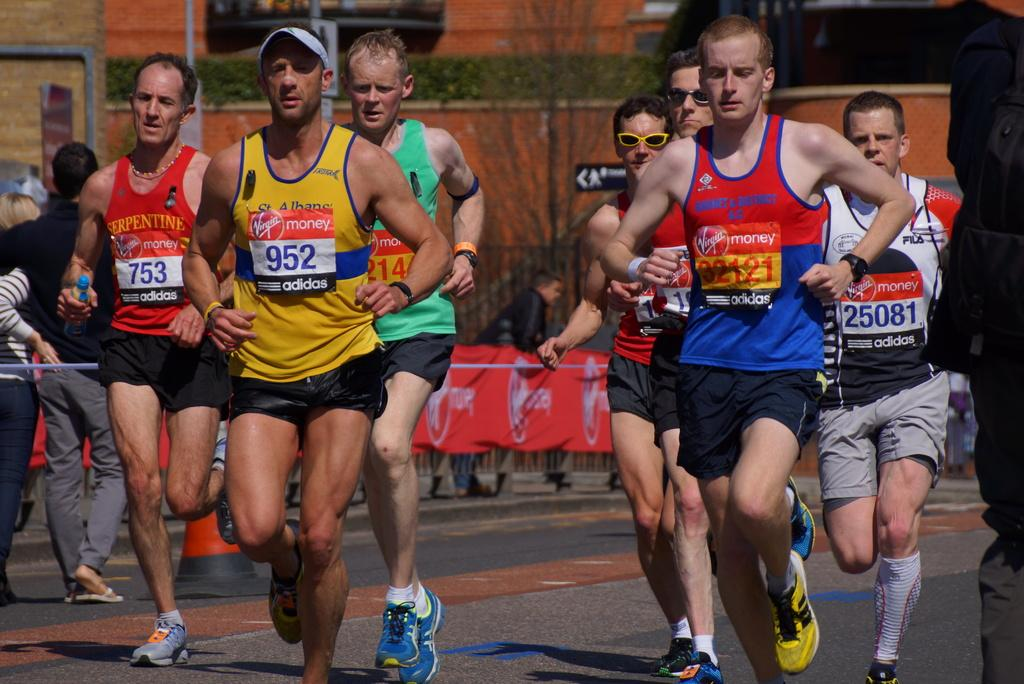<image>
Relay a brief, clear account of the picture shown. Runners in a race that is sponsored by Virgin Money. 